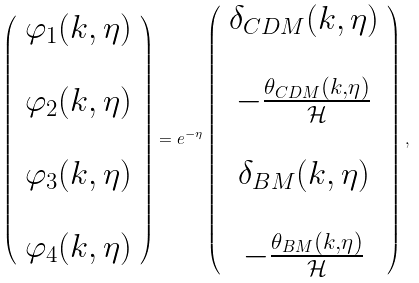Convert formula to latex. <formula><loc_0><loc_0><loc_500><loc_500>\left ( \begin{array} { c } \varphi _ { 1 } ( k , \eta ) \\ \\ \varphi _ { 2 } ( k , \eta ) \\ \\ \varphi _ { 3 } ( k , \eta ) \\ \\ \varphi _ { 4 } ( k , \eta ) \end{array} \right ) = e ^ { - \eta } \left ( \begin{array} { c } \delta _ { C D M } ( k , \eta ) \\ \\ - \frac { \theta _ { C D M } ( k , \eta ) } { \mathcal { H } } \\ \\ \delta _ { B M } ( k , \eta ) \\ \\ - \frac { \theta _ { B M } ( k , \eta ) } { \mathcal { H } } \end{array} \right ) ,</formula> 